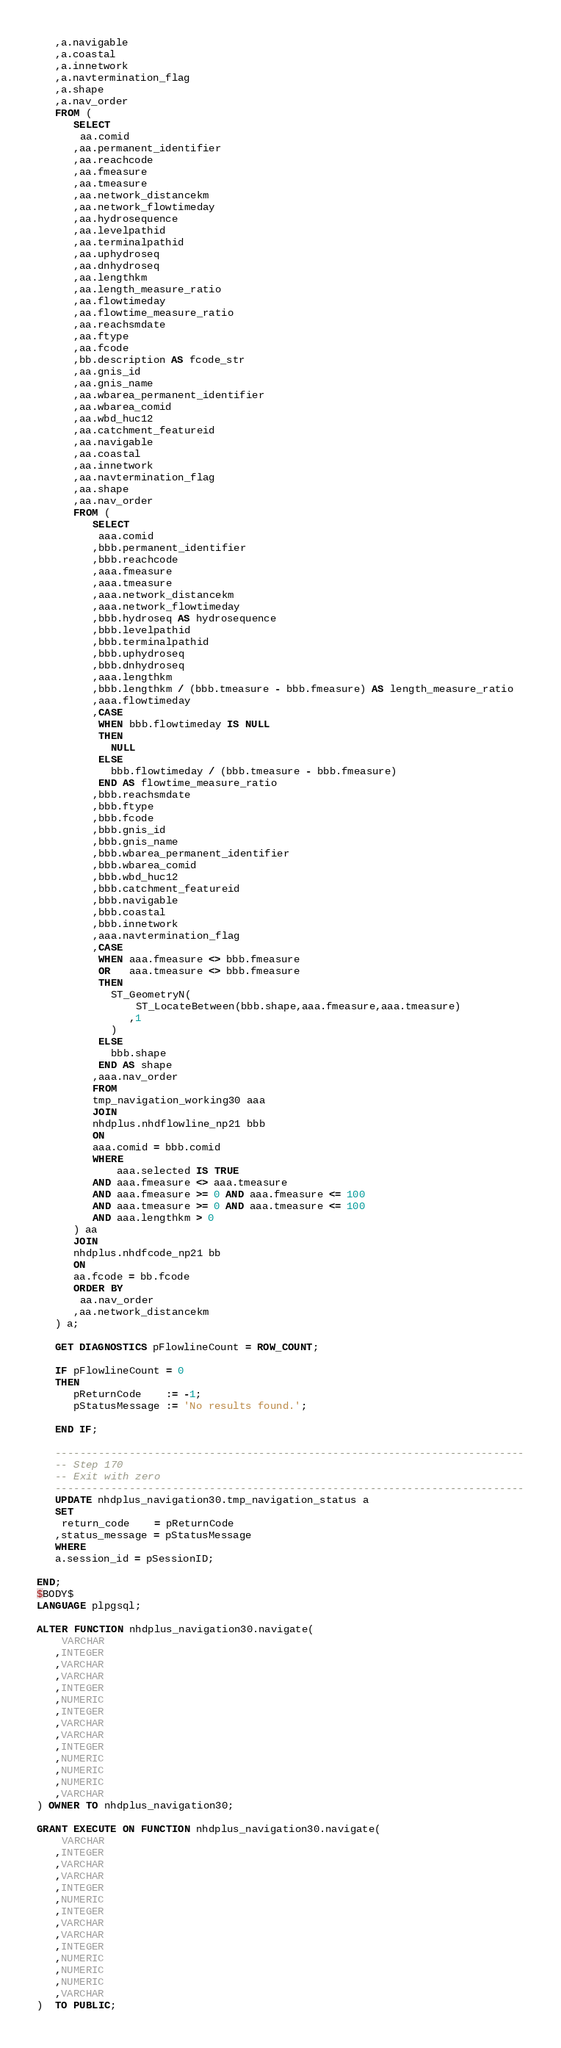Convert code to text. <code><loc_0><loc_0><loc_500><loc_500><_SQL_>   ,a.navigable
   ,a.coastal
   ,a.innetwork
   ,a.navtermination_flag
   ,a.shape
   ,a.nav_order
   FROM (
      SELECT
       aa.comid
      ,aa.permanent_identifier
      ,aa.reachcode
      ,aa.fmeasure
      ,aa.tmeasure
      ,aa.network_distancekm
      ,aa.network_flowtimeday
      ,aa.hydrosequence
      ,aa.levelpathid
      ,aa.terminalpathid
      ,aa.uphydroseq
      ,aa.dnhydroseq
      ,aa.lengthkm
      ,aa.length_measure_ratio
      ,aa.flowtimeday
      ,aa.flowtime_measure_ratio
      ,aa.reachsmdate
      ,aa.ftype
      ,aa.fcode
      ,bb.description AS fcode_str
      ,aa.gnis_id
      ,aa.gnis_name
      ,aa.wbarea_permanent_identifier
      ,aa.wbarea_comid
      ,aa.wbd_huc12
      ,aa.catchment_featureid
      ,aa.navigable
      ,aa.coastal
      ,aa.innetwork
      ,aa.navtermination_flag
      ,aa.shape
      ,aa.nav_order
      FROM (
         SELECT
          aaa.comid
         ,bbb.permanent_identifier
         ,bbb.reachcode
         ,aaa.fmeasure
         ,aaa.tmeasure
         ,aaa.network_distancekm
         ,aaa.network_flowtimeday
         ,bbb.hydroseq AS hydrosequence
         ,bbb.levelpathid
         ,bbb.terminalpathid
         ,bbb.uphydroseq
         ,bbb.dnhydroseq
         ,aaa.lengthkm
         ,bbb.lengthkm / (bbb.tmeasure - bbb.fmeasure) AS length_measure_ratio
         ,aaa.flowtimeday
         ,CASE 
          WHEN bbb.flowtimeday IS NULL
          THEN
            NULL
          ELSE
            bbb.flowtimeday / (bbb.tmeasure - bbb.fmeasure) 
          END AS flowtime_measure_ratio
         ,bbb.reachsmdate
         ,bbb.ftype
         ,bbb.fcode
         ,bbb.gnis_id
         ,bbb.gnis_name
         ,bbb.wbarea_permanent_identifier
         ,bbb.wbarea_comid
         ,bbb.wbd_huc12
         ,bbb.catchment_featureid
         ,bbb.navigable
         ,bbb.coastal
         ,bbb.innetwork
         ,aaa.navtermination_flag
         ,CASE
          WHEN aaa.fmeasure <> bbb.fmeasure
          OR   aaa.tmeasure <> bbb.fmeasure
          THEN
            ST_GeometryN(
                ST_LocateBetween(bbb.shape,aaa.fmeasure,aaa.tmeasure)
               ,1
            )
          ELSE
            bbb.shape
          END AS shape
         ,aaa.nav_order
         FROM
         tmp_navigation_working30 aaa
         JOIN
         nhdplus.nhdflowline_np21 bbb
         ON
         aaa.comid = bbb.comid
         WHERE
             aaa.selected IS TRUE
         AND aaa.fmeasure <> aaa.tmeasure
         AND aaa.fmeasure >= 0 AND aaa.fmeasure <= 100
         AND aaa.tmeasure >= 0 AND aaa.tmeasure <= 100
         AND aaa.lengthkm > 0
      ) aa
      JOIN
      nhdplus.nhdfcode_np21 bb
      ON
      aa.fcode = bb.fcode
      ORDER BY
       aa.nav_order
      ,aa.network_distancekm
   ) a;
   
   GET DIAGNOSTICS pFlowlineCount = ROW_COUNT;
   
   IF pFlowlineCount = 0
   THEN
      pReturnCode    := -1;
      pStatusMessage := 'No results found.';
   
   END IF;

   ----------------------------------------------------------------------------
   -- Step 170
   -- Exit with zero
   ----------------------------------------------------------------------------
   UPDATE nhdplus_navigation30.tmp_navigation_status a
   SET
    return_code    = pReturnCode
   ,status_message = pStatusMessage
   WHERE
   a.session_id = pSessionID;

END;
$BODY$
LANGUAGE plpgsql;

ALTER FUNCTION nhdplus_navigation30.navigate(
    VARCHAR
   ,INTEGER
   ,VARCHAR
   ,VARCHAR
   ,INTEGER
   ,NUMERIC
   ,INTEGER
   ,VARCHAR
   ,VARCHAR
   ,INTEGER
   ,NUMERIC
   ,NUMERIC
   ,NUMERIC
   ,VARCHAR
) OWNER TO nhdplus_navigation30;

GRANT EXECUTE ON FUNCTION nhdplus_navigation30.navigate(
    VARCHAR
   ,INTEGER
   ,VARCHAR
   ,VARCHAR
   ,INTEGER
   ,NUMERIC
   ,INTEGER
   ,VARCHAR
   ,VARCHAR
   ,INTEGER
   ,NUMERIC
   ,NUMERIC
   ,NUMERIC
   ,VARCHAR
)  TO PUBLIC;

</code> 